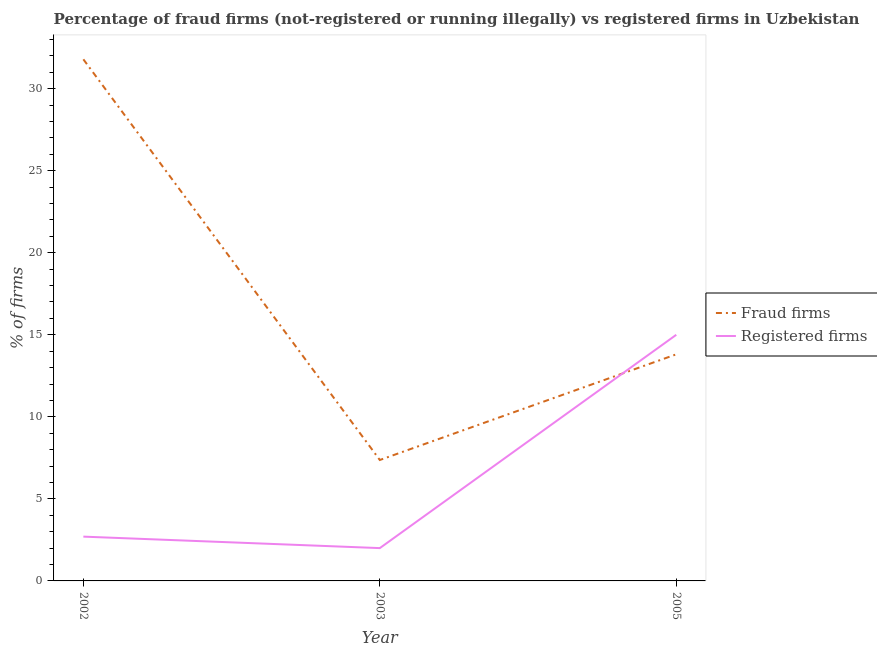How many different coloured lines are there?
Offer a terse response. 2. Does the line corresponding to percentage of registered firms intersect with the line corresponding to percentage of fraud firms?
Your answer should be very brief. Yes. What is the percentage of fraud firms in 2003?
Your answer should be very brief. 7.37. Across all years, what is the minimum percentage of registered firms?
Offer a terse response. 2. What is the total percentage of registered firms in the graph?
Ensure brevity in your answer.  19.7. What is the difference between the percentage of fraud firms in 2002 and that in 2005?
Offer a terse response. 17.98. What is the difference between the percentage of fraud firms in 2003 and the percentage of registered firms in 2002?
Your answer should be very brief. 4.67. What is the average percentage of fraud firms per year?
Provide a succinct answer. 17.66. In the year 2002, what is the difference between the percentage of registered firms and percentage of fraud firms?
Keep it short and to the point. -29.09. In how many years, is the percentage of fraud firms greater than 14 %?
Provide a succinct answer. 1. What is the ratio of the percentage of fraud firms in 2002 to that in 2005?
Your response must be concise. 2.3. Is the percentage of fraud firms in 2003 less than that in 2005?
Offer a terse response. Yes. Is the difference between the percentage of registered firms in 2002 and 2005 greater than the difference between the percentage of fraud firms in 2002 and 2005?
Provide a succinct answer. No. What is the difference between the highest and the second highest percentage of fraud firms?
Offer a very short reply. 17.98. What is the difference between the highest and the lowest percentage of fraud firms?
Ensure brevity in your answer.  24.42. In how many years, is the percentage of fraud firms greater than the average percentage of fraud firms taken over all years?
Keep it short and to the point. 1. Is the sum of the percentage of registered firms in 2003 and 2005 greater than the maximum percentage of fraud firms across all years?
Provide a short and direct response. No. Does the percentage of fraud firms monotonically increase over the years?
Provide a succinct answer. No. Is the percentage of fraud firms strictly greater than the percentage of registered firms over the years?
Keep it short and to the point. No. Is the percentage of fraud firms strictly less than the percentage of registered firms over the years?
Your response must be concise. No. How many years are there in the graph?
Offer a very short reply. 3. What is the difference between two consecutive major ticks on the Y-axis?
Keep it short and to the point. 5. Are the values on the major ticks of Y-axis written in scientific E-notation?
Provide a succinct answer. No. Does the graph contain grids?
Provide a succinct answer. No. Where does the legend appear in the graph?
Provide a succinct answer. Center right. How are the legend labels stacked?
Make the answer very short. Vertical. What is the title of the graph?
Offer a very short reply. Percentage of fraud firms (not-registered or running illegally) vs registered firms in Uzbekistan. What is the label or title of the Y-axis?
Offer a very short reply. % of firms. What is the % of firms in Fraud firms in 2002?
Provide a short and direct response. 31.79. What is the % of firms in Registered firms in 2002?
Your answer should be compact. 2.7. What is the % of firms in Fraud firms in 2003?
Offer a very short reply. 7.37. What is the % of firms in Fraud firms in 2005?
Give a very brief answer. 13.81. Across all years, what is the maximum % of firms of Fraud firms?
Offer a terse response. 31.79. Across all years, what is the minimum % of firms in Fraud firms?
Provide a short and direct response. 7.37. Across all years, what is the minimum % of firms of Registered firms?
Offer a very short reply. 2. What is the total % of firms in Fraud firms in the graph?
Ensure brevity in your answer.  52.97. What is the total % of firms in Registered firms in the graph?
Make the answer very short. 19.7. What is the difference between the % of firms in Fraud firms in 2002 and that in 2003?
Provide a succinct answer. 24.42. What is the difference between the % of firms of Registered firms in 2002 and that in 2003?
Offer a very short reply. 0.7. What is the difference between the % of firms in Fraud firms in 2002 and that in 2005?
Provide a succinct answer. 17.98. What is the difference between the % of firms of Registered firms in 2002 and that in 2005?
Give a very brief answer. -12.3. What is the difference between the % of firms of Fraud firms in 2003 and that in 2005?
Your response must be concise. -6.44. What is the difference between the % of firms in Registered firms in 2003 and that in 2005?
Give a very brief answer. -13. What is the difference between the % of firms of Fraud firms in 2002 and the % of firms of Registered firms in 2003?
Offer a terse response. 29.79. What is the difference between the % of firms in Fraud firms in 2002 and the % of firms in Registered firms in 2005?
Keep it short and to the point. 16.79. What is the difference between the % of firms of Fraud firms in 2003 and the % of firms of Registered firms in 2005?
Your answer should be compact. -7.63. What is the average % of firms in Fraud firms per year?
Make the answer very short. 17.66. What is the average % of firms of Registered firms per year?
Your answer should be compact. 6.57. In the year 2002, what is the difference between the % of firms in Fraud firms and % of firms in Registered firms?
Offer a very short reply. 29.09. In the year 2003, what is the difference between the % of firms of Fraud firms and % of firms of Registered firms?
Provide a succinct answer. 5.37. In the year 2005, what is the difference between the % of firms in Fraud firms and % of firms in Registered firms?
Make the answer very short. -1.19. What is the ratio of the % of firms in Fraud firms in 2002 to that in 2003?
Provide a succinct answer. 4.31. What is the ratio of the % of firms in Registered firms in 2002 to that in 2003?
Provide a succinct answer. 1.35. What is the ratio of the % of firms of Fraud firms in 2002 to that in 2005?
Ensure brevity in your answer.  2.3. What is the ratio of the % of firms in Registered firms in 2002 to that in 2005?
Your answer should be compact. 0.18. What is the ratio of the % of firms of Fraud firms in 2003 to that in 2005?
Offer a terse response. 0.53. What is the ratio of the % of firms in Registered firms in 2003 to that in 2005?
Ensure brevity in your answer.  0.13. What is the difference between the highest and the second highest % of firms of Fraud firms?
Your response must be concise. 17.98. What is the difference between the highest and the lowest % of firms in Fraud firms?
Your answer should be compact. 24.42. What is the difference between the highest and the lowest % of firms of Registered firms?
Offer a very short reply. 13. 